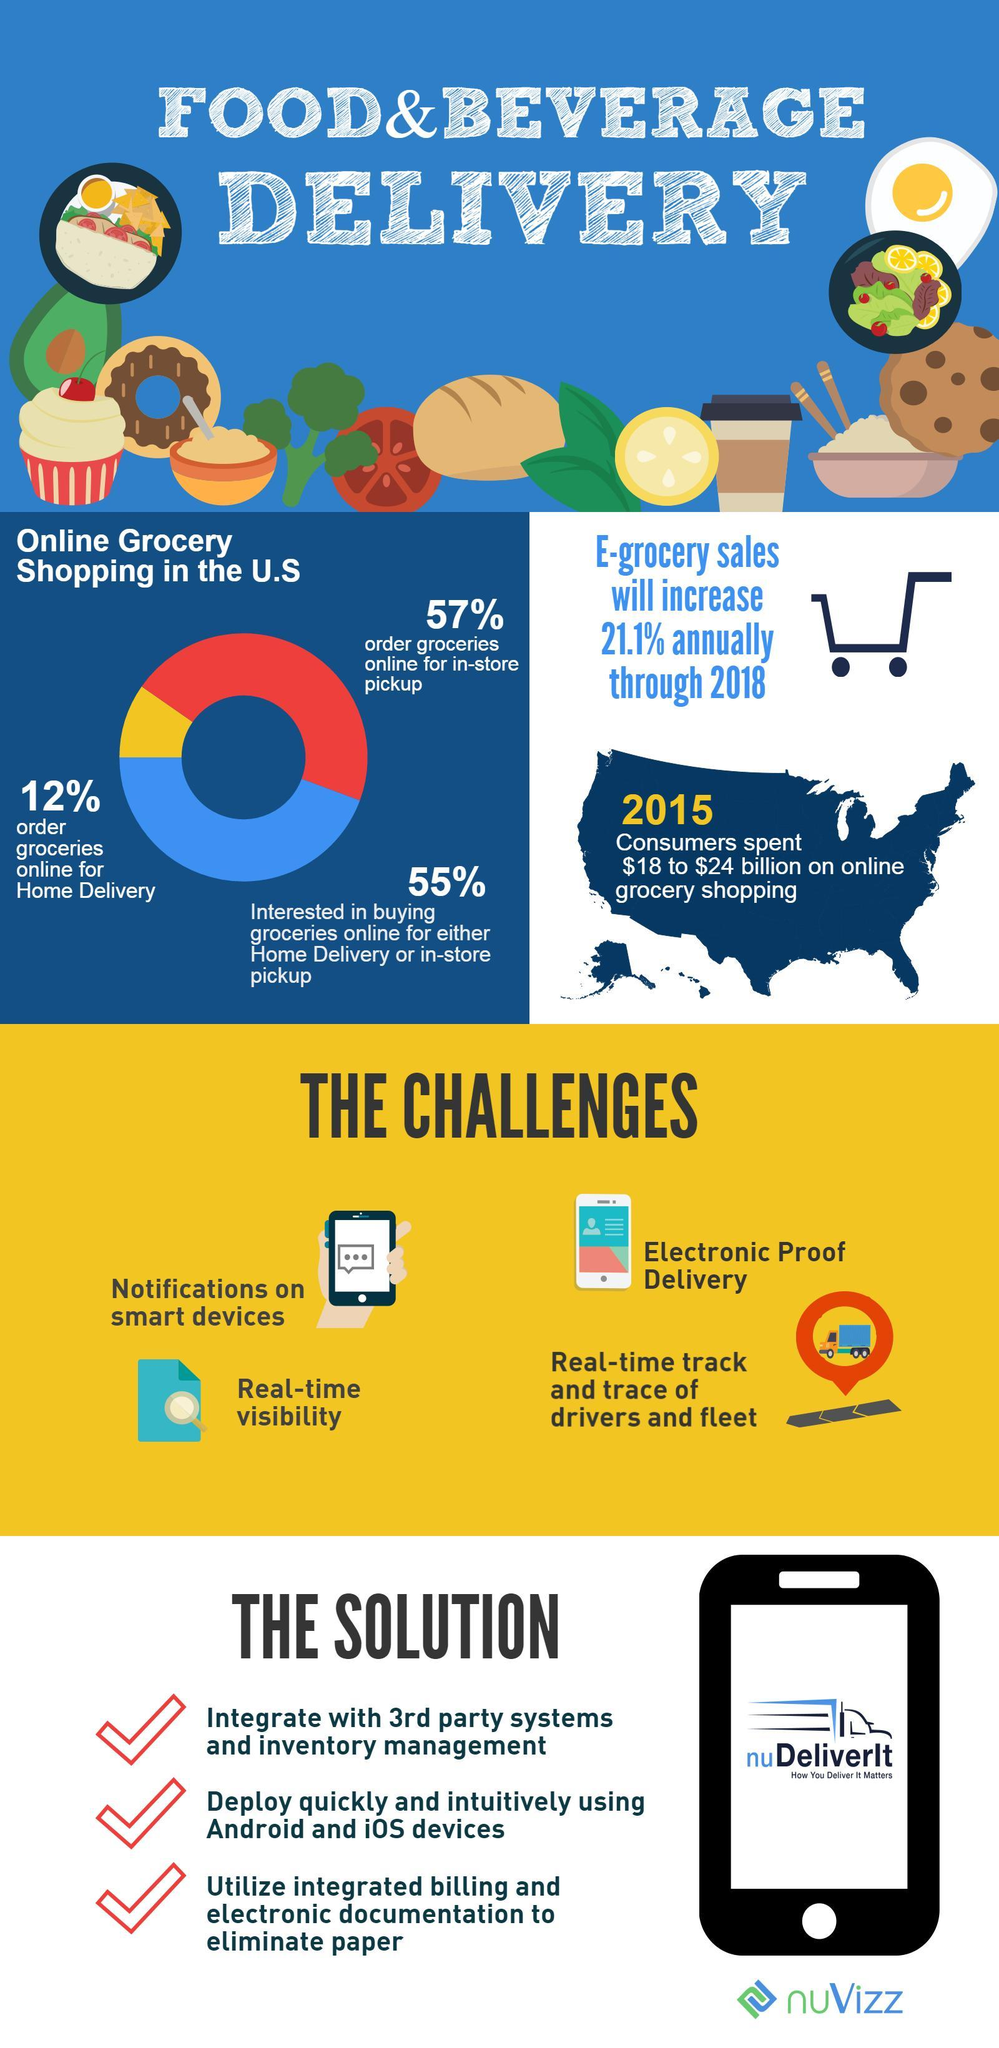Which has the highest share in online grocery shopping in the U.S?
Answer the question with a short phrase. Interested in buying groceries online for either home delivery or in-store pickup 